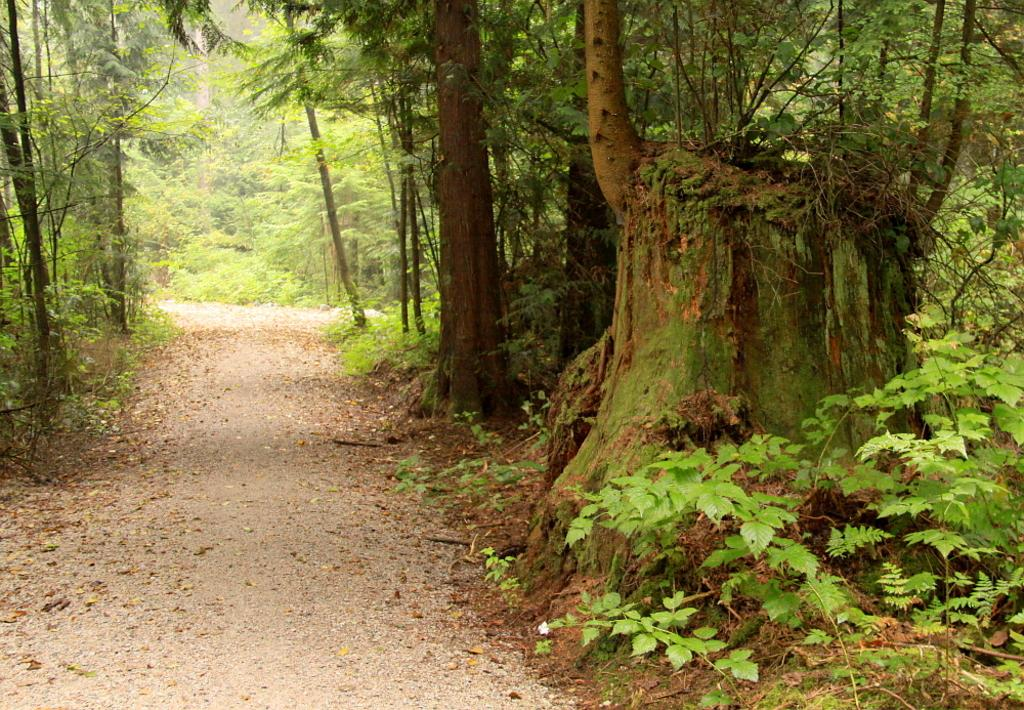What is present on the path in the image? There are leaves on the path in the image. What type of vegetation can be seen in the image? There are plants in the image. What can be seen in the background of the image? There are trees in the background of the image. What type of advertisement can be seen on the path in the image? There is no advertisement present on the path in the image. What stick is being used by the plants in the image? There is no stick being used by the plants in the image. 